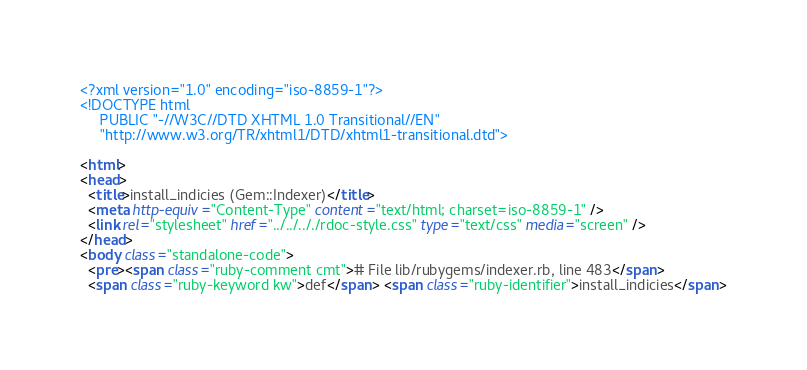<code> <loc_0><loc_0><loc_500><loc_500><_HTML_><?xml version="1.0" encoding="iso-8859-1"?>
<!DOCTYPE html 
     PUBLIC "-//W3C//DTD XHTML 1.0 Transitional//EN"
     "http://www.w3.org/TR/xhtml1/DTD/xhtml1-transitional.dtd">

<html>
<head>
  <title>install_indicies (Gem::Indexer)</title>
  <meta http-equiv="Content-Type" content="text/html; charset=iso-8859-1" />
  <link rel="stylesheet" href="../../.././rdoc-style.css" type="text/css" media="screen" />
</head>
<body class="standalone-code">
  <pre><span class="ruby-comment cmt"># File lib/rubygems/indexer.rb, line 483</span>
  <span class="ruby-keyword kw">def</span> <span class="ruby-identifier">install_indicies</span></code> 